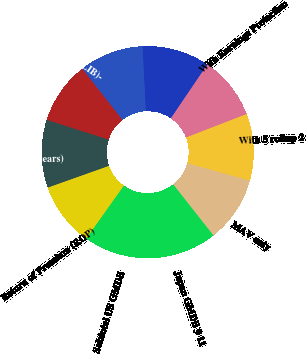Convert chart. <chart><loc_0><loc_0><loc_500><loc_500><pie_chart><fcel>MAV only<fcel>With 5 rollup 2<fcel>With Earnings Protection<fcel>With 5 rollup & EPB<fcel>Asset Protection Benefit (APB)<fcel>Lifetime Income Benefit (LIB)-<fcel>Reset 6 (5-7 years)<fcel>Return of Premium (ROP)<fcel>Subtotal US GMDB<fcel>Japan GMDB 9 11<nl><fcel>10.08%<fcel>10.17%<fcel>9.64%<fcel>10.26%<fcel>9.82%<fcel>9.49%<fcel>10.35%<fcel>9.73%<fcel>9.93%<fcel>10.53%<nl></chart> 